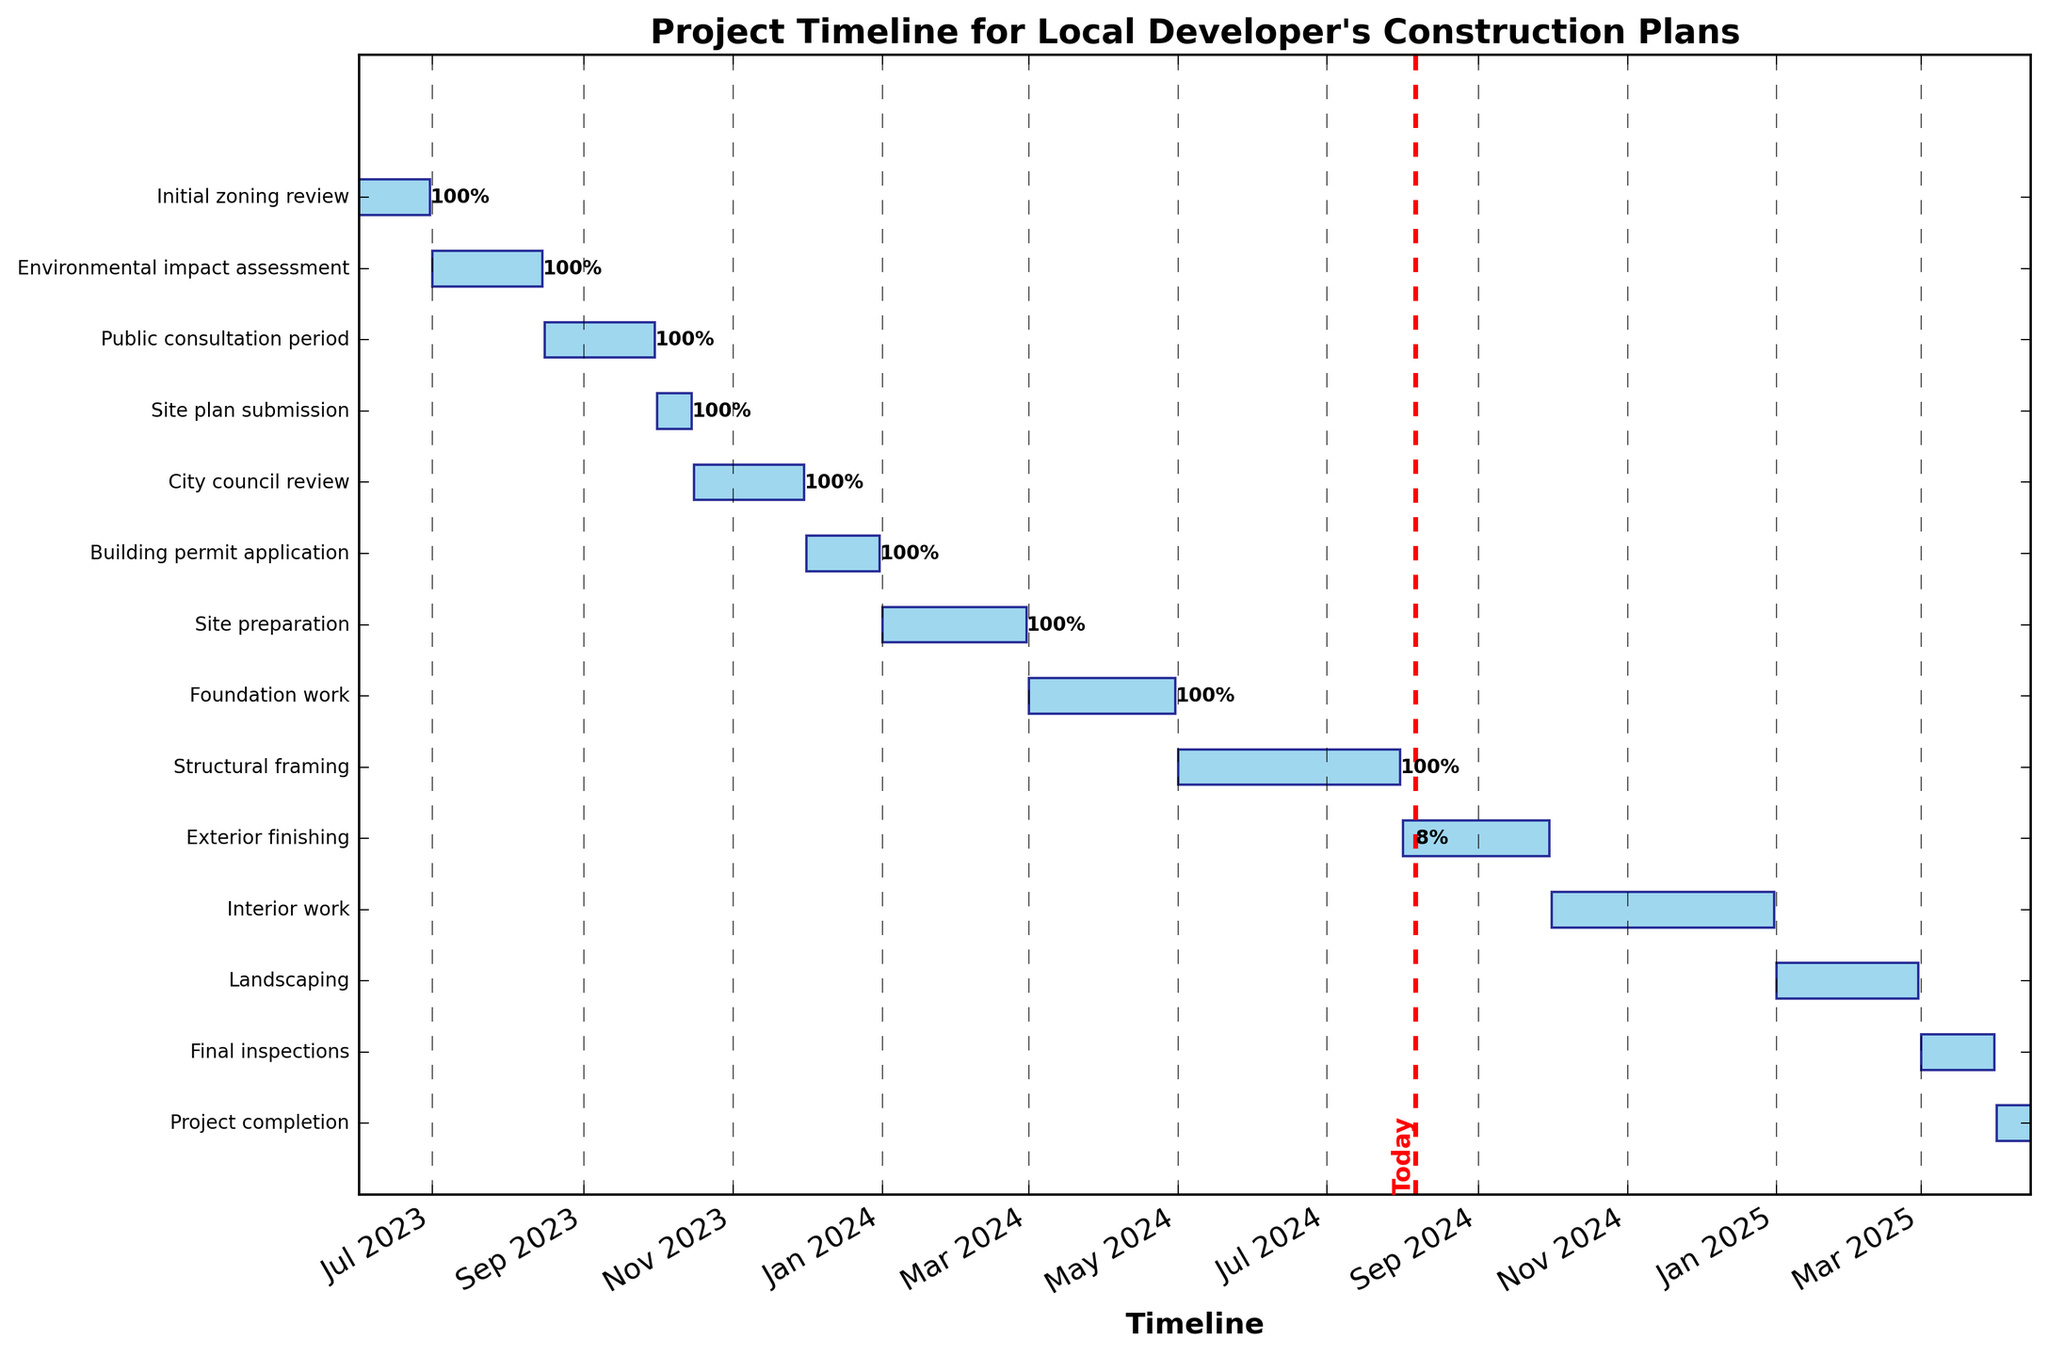When does the "City council review" task start? The "City council review" task starts at the leftmost point of its corresponding bar on the Gantt chart, which aligns with the date label on the x-axis.
Answer: 2023-10-16 Which task has the longest duration? By comparing the length of the horizontal bars, the longest bar indicates the task with the longest duration. This corresponds to the "Structural framing" task.
Answer: Structural framing How many tasks are scheduled to start in 2024? Review the start dates within the bars for 2024. The tasks with start dates falling in 2024 are "Site preparation" (2024-01-01), "Foundation work" (2024-03-01), "Structural framing" (2024-05-01), "Exterior finishing" (2024-08-01), and "Interior work" (2024-10-01).
Answer: 5 Which tasks have completion percentages indicated on the chart? The tasks that have a completion percentage are those whose bars contain a text label showing a percentage, due to either their task ending or spanning the current date line. These tasks are: "Initial zoning review," "Environmental impact assessment," "Public consultation period," "Site plan submission," "City council review," and "Building permit application."
Answer: Initial zoning review, Environmental impact assessment, Public consultation period, Site plan submission, City council review, Building permit application What is the total duration for "Site preparation" and "Foundation work"? The duration of "Site preparation" is 60 days, and the duration of "Foundation work" is also evidenced by comparing the respective bar lengths. Adding them gives 60 + 61 (February is not a leap year) = 121 days.
Answer: 121 days Which task ends closest to today's date? Identify today's date on the Gantt chart with the red vertical line and find the task whose right end (end date) is nearest to this line. This is the "Building permit application" task which ends on 2023-12-31.
Answer: Building permit application How much earlier does the "Public consultation period" end compared to the "Site plan submission" start? The "Public consultation period" ends on 2023-09-30, and the "Site plan submission" starts on 2023-10-01. The difference between these dates is 1 day.
Answer: 1 day Which task is performed just before "Environmental impact assessment"? On the Gantt chart, the sequence of tasks from top to bottom shows progression. The task immediately above "Environmental impact assessment" in the chart is "Initial zoning review".
Answer: Initial zoning review 